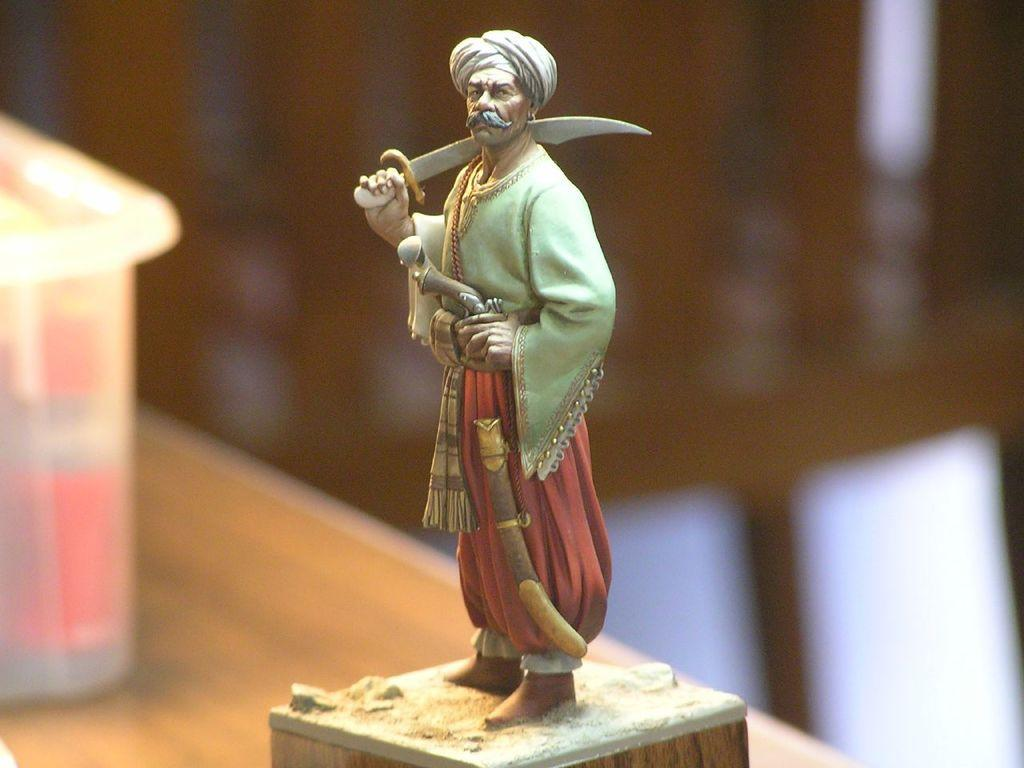What type of object is depicted in the image? There is a sculpture of a person in the image. What is the person in the sculpture doing? The person in the sculpture is standing and holding a sword. Are there any other sculptures or objects on the table in the image? Yes, there is a sculpture on a table and a box on the table in the image. Can you describe the background of the image? The background of the image is blurry. What type of meal is being prepared on the table in the image? There is no meal being prepared in the image; it features sculptures and a box on a table. What direction is the person in the sculpture facing in the image? The provided facts do not specify the direction the person in the sculpture is facing. 